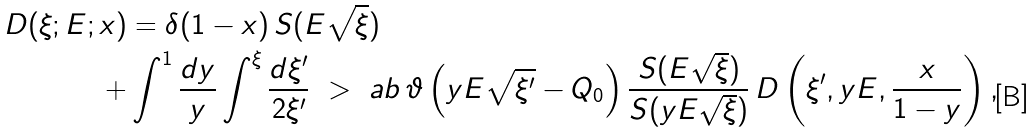<formula> <loc_0><loc_0><loc_500><loc_500>D ( \xi ; E ; x ) & = \delta ( 1 - x ) \, S ( E \sqrt { \xi } ) \\ + & \int ^ { 1 } \frac { d y } { y } \int ^ { \xi } \frac { d \xi ^ { \prime } } { 2 \xi ^ { \prime } } \ > \ a b \, \vartheta \left ( y E \sqrt { \xi ^ { \prime } } - Q _ { 0 } \right ) \frac { S ( E \sqrt { \xi } ) } { S ( y E \sqrt { \xi } ) } \, D \left ( \xi ^ { \prime } , y E , \frac { x } { 1 - y } \right ) ,</formula> 